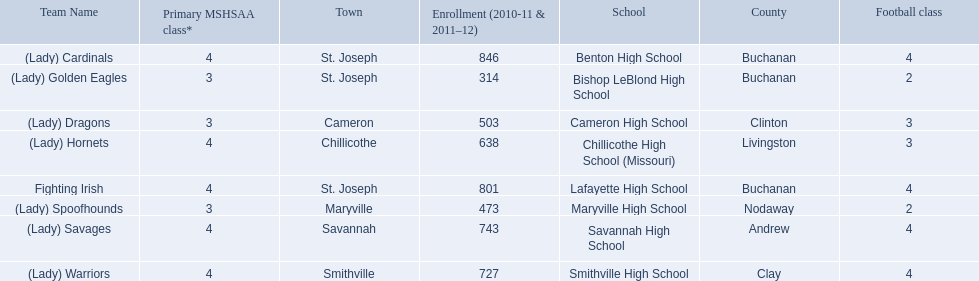What schools are located in st. joseph? Benton High School, Bishop LeBlond High School, Lafayette High School. Which st. joseph schools have more then 800 enrollment  for 2010-11 7 2011-12? Benton High School, Lafayette High School. What is the name of the st. joseph school with 800 or more enrollment's team names is a not a (lady)? Lafayette High School. How many are enrolled at each school? Benton High School, 846, Bishop LeBlond High School, 314, Cameron High School, 503, Chillicothe High School (Missouri), 638, Lafayette High School, 801, Maryville High School, 473, Savannah High School, 743, Smithville High School, 727. Which school has at only three football classes? Cameron High School, 3, Chillicothe High School (Missouri), 3. Which school has 638 enrolled and 3 football classes? Chillicothe High School (Missouri). 